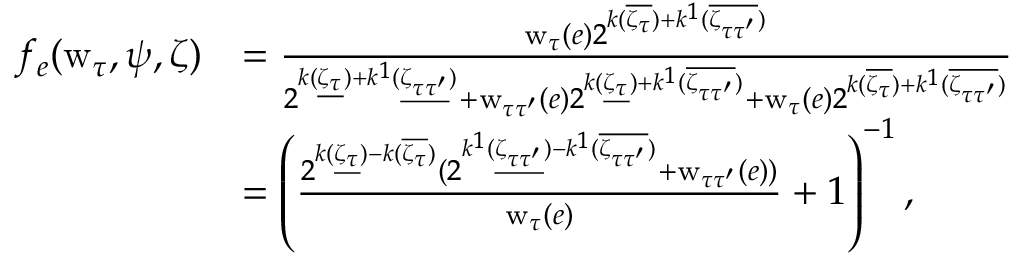<formula> <loc_0><loc_0><loc_500><loc_500>\begin{array} { r l } { f _ { e } ( w _ { \tau } , \psi , \zeta ) } & { = \frac { w _ { \tau } ( e ) 2 ^ { k ( \overline { { \zeta _ { \tau } } } ) + k ^ { 1 } ( \overline { { \zeta _ { \tau \tau ^ { \prime } } } } ) } } { 2 ^ { k ( \underline { { \zeta _ { \tau } } } ) + k ^ { 1 } ( \underline { { \zeta _ { \tau \tau ^ { \prime } } } } ) } + w _ { \tau \tau ^ { \prime } } ( e ) 2 ^ { k ( \underline { { \zeta _ { \tau } } } ) + k ^ { 1 } ( \overline { { \zeta _ { \tau \tau ^ { \prime } } } } ) } + w _ { \tau } ( e ) 2 ^ { k ( \overline { { \zeta _ { \tau } } } ) + k ^ { 1 } ( \overline { { \zeta _ { \tau \tau ^ { \prime } } } } ) } } } \\ & { = \left ( \frac { 2 ^ { k ( \underline { { \zeta _ { \tau } } } ) - k ( \overline { { \zeta _ { \tau } } } ) } ( 2 ^ { k ^ { 1 } ( \underline { { \zeta _ { \tau \tau ^ { \prime } } } } ) - k ^ { 1 } ( \overline { { \zeta _ { \tau \tau ^ { \prime } } } } ) } + w _ { \tau \tau ^ { \prime } } ( e ) ) } { w _ { \tau } ( e ) } + 1 \right ) ^ { - 1 } , } \end{array}</formula> 